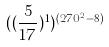Convert formula to latex. <formula><loc_0><loc_0><loc_500><loc_500>( ( \frac { 5 } { 1 7 } ) ^ { 1 } ) ^ { ( 2 7 0 ^ { 2 } - 8 ) }</formula> 